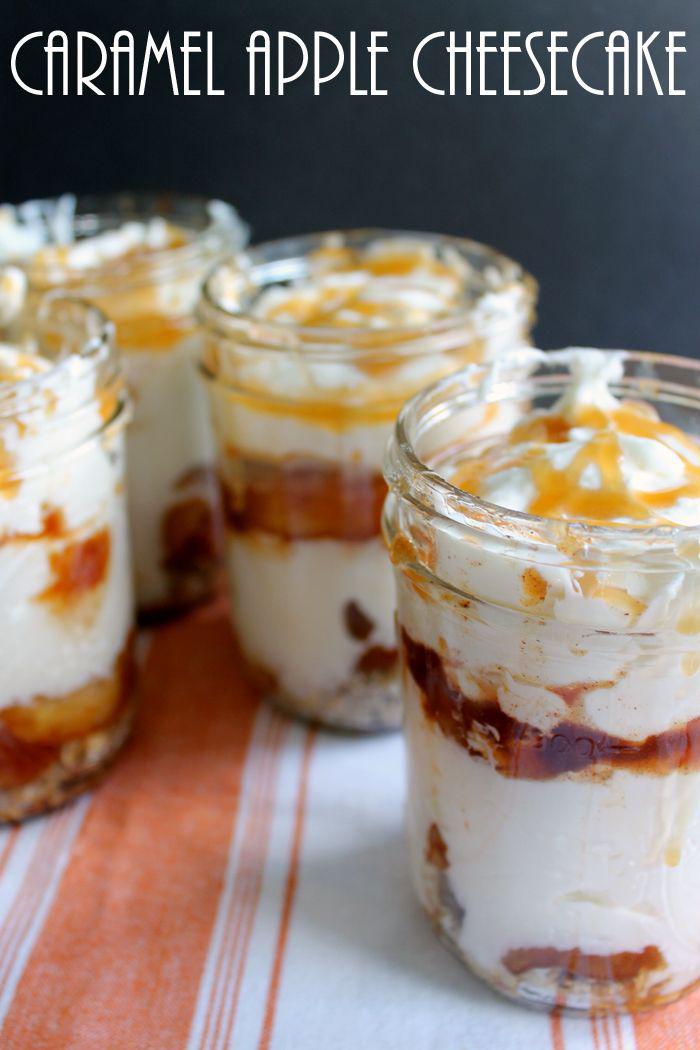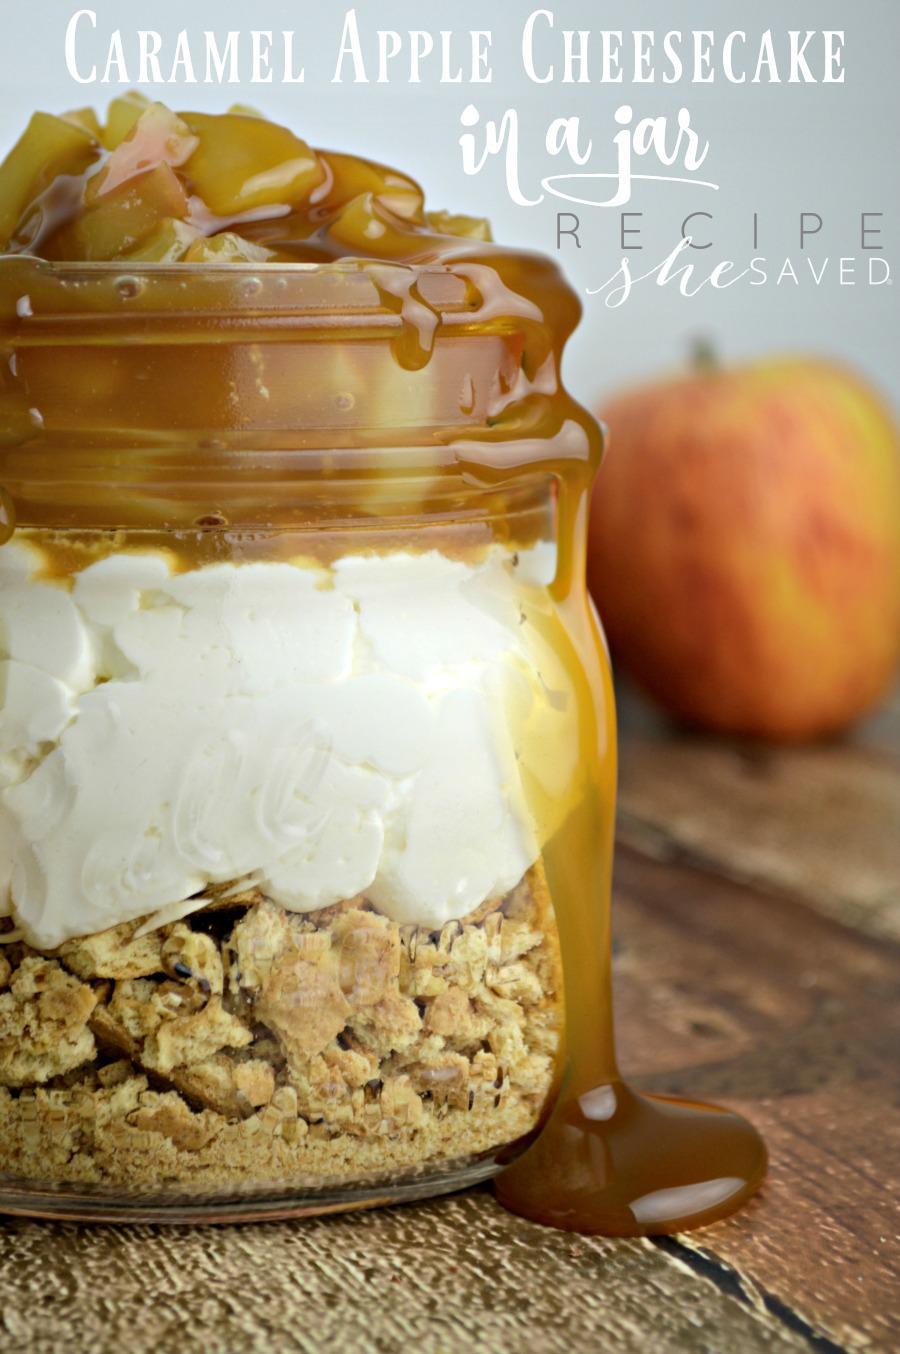The first image is the image on the left, the second image is the image on the right. Analyze the images presented: Is the assertion "An image shows a dessert with two white layers, no whipped cream on top, and caramel drizzled down the exterior of the serving jar." valid? Answer yes or no. No. 